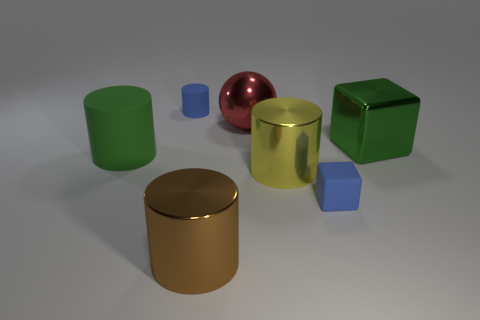Can you tell me what materials the objects in the image seem to be made of? The objects in the image appear to be made from different materials. The cylindrical objects, one of which is a large yellow cylinder, seem to have a matte finish that could suggest a plastic or rubber material. The sphere has a reflective surface that implies it could be metallic, and the cubes also have a matte finish but in two different colors, which could mean they are made of plastic or painted wood. 